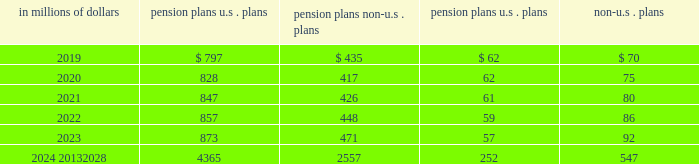Investment strategy the company 2019s global pension and postretirement funds 2019 investment strategy is to invest in a prudent manner for the exclusive purpose of providing benefits to participants .
The investment strategies are targeted to produce a total return that , when combined with the company 2019s contributions to the funds , will maintain the funds 2019 ability to meet all required benefit obligations .
Risk is controlled through diversification of asset types and investments in domestic and international equities , fixed income securities and cash and short-term investments .
The target asset allocation in most locations outside the u.s .
Is primarily in equity and debt securities .
These allocations may vary by geographic region and country depending on the nature of applicable obligations and various other regional considerations .
The wide variation in the actual range of plan asset allocations for the funded non-u.s .
Plans is a result of differing local statutory requirements and economic conditions .
For example , in certain countries local law requires that all pension plan assets must be invested in fixed income investments , government funds or local-country securities .
Significant concentrations of risk in plan assets the assets of the company 2019s pension plans are diversified to limit the impact of any individual investment .
The u.s .
Qualified pension plan is diversified across multiple asset classes , with publicly traded fixed income , hedge funds , publicly traded equity and real estate representing the most significant asset allocations .
Investments in these four asset classes are further diversified across funds , managers , strategies , vintages , sectors and geographies , depending on the specific characteristics of each asset class .
The pension assets for the company 2019s non-u.s .
Significant plans are primarily invested in publicly traded fixed income and publicly traded equity securities .
Oversight and risk management practices the framework for the company 2019s pension oversight process includes monitoring of retirement plans by plan fiduciaries and/or management at the global , regional or country level , as appropriate .
Independent risk management contributes to the risk oversight and monitoring for the company 2019s u.s .
Qualified pension plan and non-u.s .
Significant pension plans .
Although the specific components of the oversight process are tailored to the requirements of each region , country and plan , the following elements are common to the company 2019s monitoring and risk management process : 2022 periodic asset/liability management studies and strategic asset allocation reviews ; 2022 periodic monitoring of funding levels and funding ratios ; 2022 periodic monitoring of compliance with asset allocation guidelines ; 2022 periodic monitoring of asset class and/or investment manager performance against benchmarks ; and 2022 periodic risk capital analysis and stress testing .
Estimated future benefit payments the company expects to pay the following estimated benefit payments in future years: .

What are total estimated future benefit payments in millions for 2019? 
Computations: table_sum(2019, none)
Answer: 1364.0. 